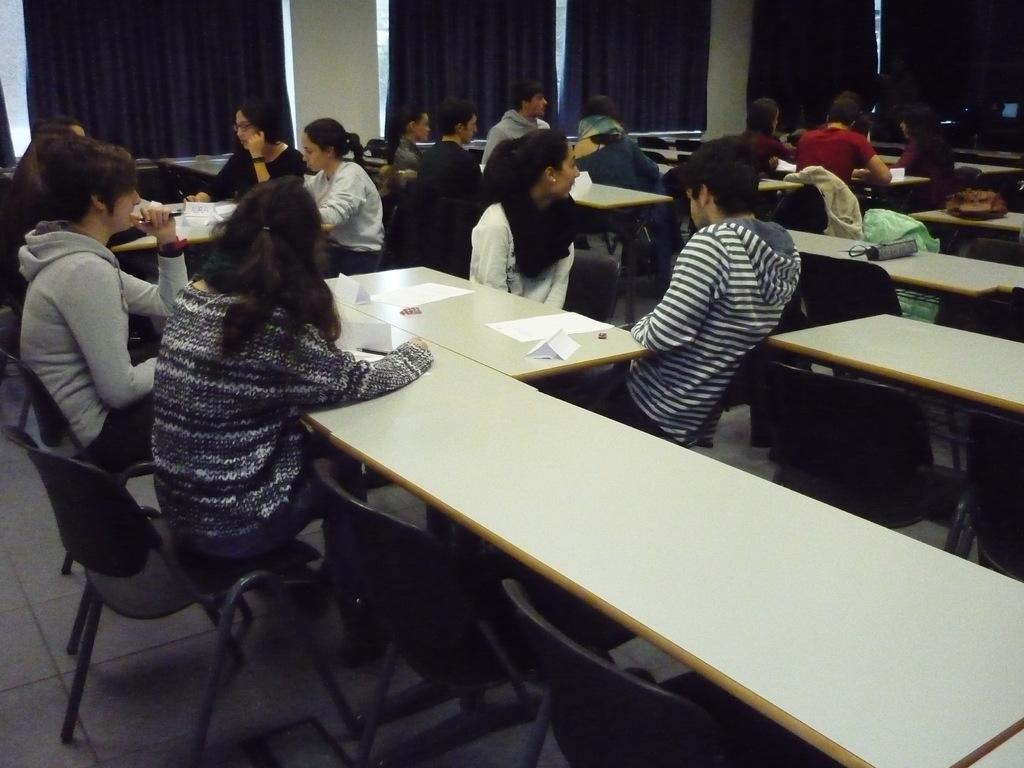What is happening in the image involving the group of people? The people in the image are sitting and talking with each other. What objects are in front of the people? There are tables in front of the people. What can be seen on the tables? There are papers on the tables. What color is the shirt of the person who is thinking about elbow grease in the image? There is no person in the image thinking about elbow grease, and no one's shirt color is mentioned. 